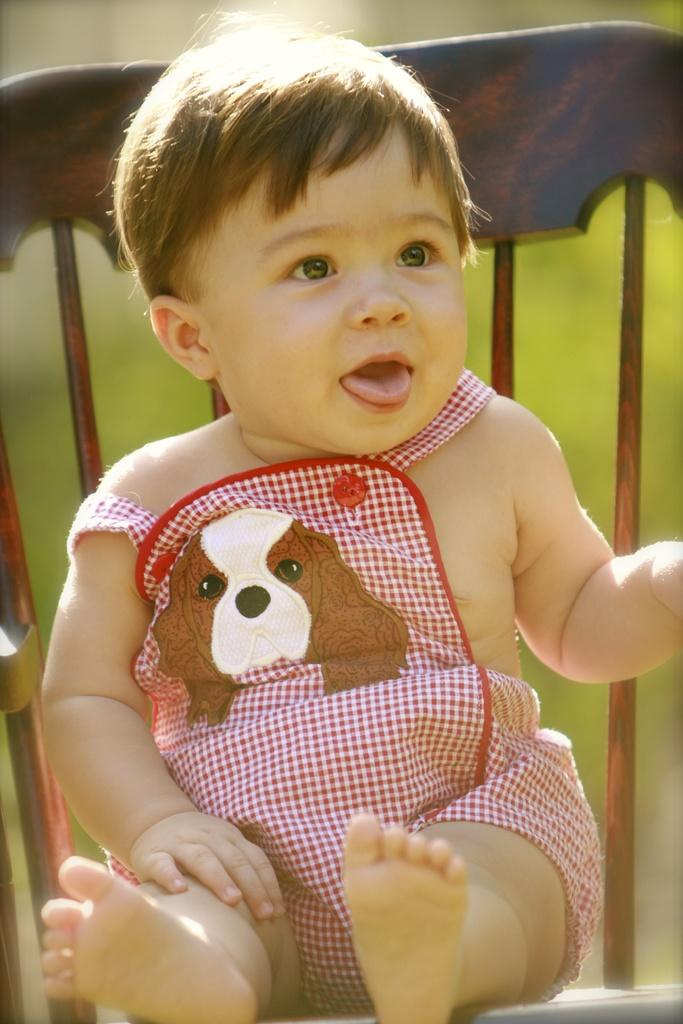What is the main subject of the image? There is a child in the image. Can you describe the child's clothing? The child is wearing a pink and white dress. What is the child doing in the image? The child is sitting on a chair. How would you describe the background of the image? The background of the image is blurry. Where is the nest located in the image? There is no nest present in the image. What type of basket is being used by the child in the image? There is no basket present in the image. 